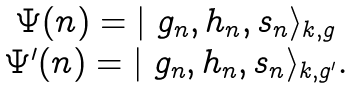Convert formula to latex. <formula><loc_0><loc_0><loc_500><loc_500>\begin{array} { c } \Psi ( n ) = | \ g _ { n } , h _ { n } , s _ { n } \rangle _ { k , g } \\ \Psi ^ { \prime } ( n ) = | \ g _ { n } , h _ { n } , s _ { n } \rangle _ { k , g ^ { \prime } } . \end{array}</formula> 